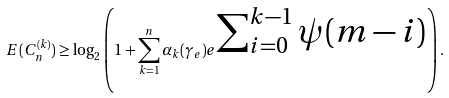<formula> <loc_0><loc_0><loc_500><loc_500>E ( C _ { n } ^ { ( k ) } ) \geq \log _ { 2 } \left ( 1 + \sum _ { k = 1 } ^ { n } \alpha _ { k } ( \gamma _ { e } ) e ^ { \begin{matrix} \sum _ { i = 0 } ^ { k - 1 } \psi ( m - i ) \end{matrix} } \right ) .</formula> 